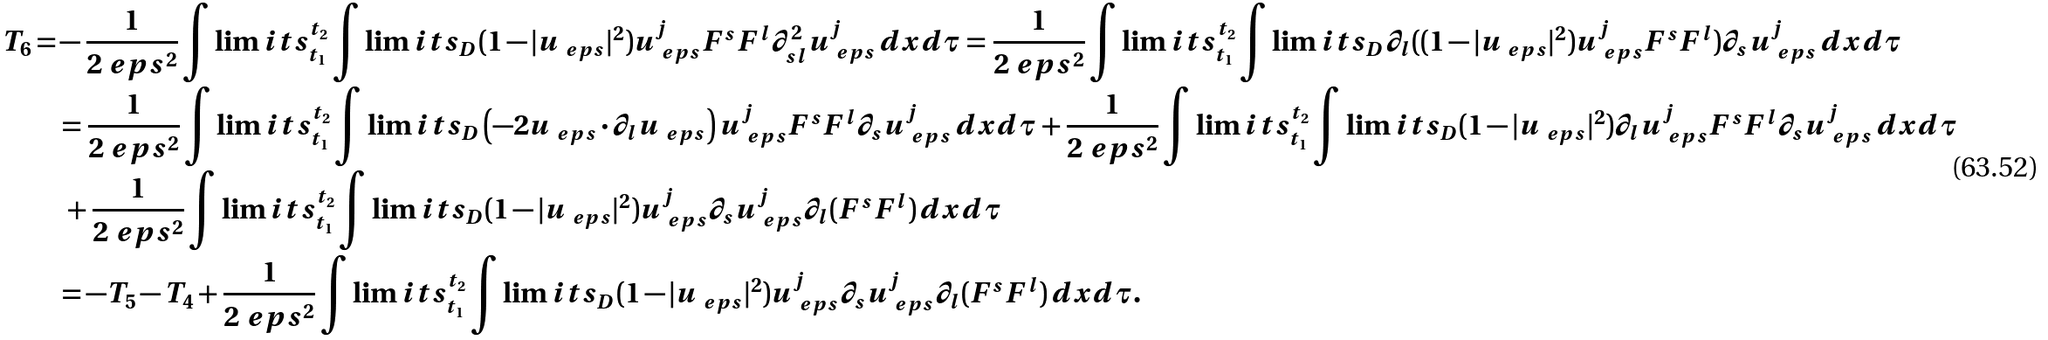<formula> <loc_0><loc_0><loc_500><loc_500>T _ { 6 } = & - \frac { 1 } { 2 \ e p s ^ { 2 } } \int \lim i t s _ { t _ { 1 } } ^ { t _ { 2 } } \int \lim i t s _ { D } ( 1 - | u _ { \ e p s } | ^ { 2 } ) u _ { \ e p s } ^ { j } F ^ { s } F ^ { l } \partial ^ { 2 } _ { s l } u _ { \ e p s } ^ { j } \, d x d \tau = \frac { 1 } { 2 \ e p s ^ { 2 } } \int \lim i t s _ { t _ { 1 } } ^ { t _ { 2 } } \int \lim i t s _ { D } \partial _ { l } ( ( 1 - | u _ { \ e p s } | ^ { 2 } ) u _ { \ e p s } ^ { j } F ^ { s } F ^ { l } ) \partial _ { s } u _ { \ e p s } ^ { j } \, d x d \tau \\ & = \frac { 1 } { 2 \ e p s ^ { 2 } } \int \lim i t s _ { t _ { 1 } } ^ { t _ { 2 } } \int \lim i t s _ { D } \left ( - 2 u _ { \ e p s } \cdot \partial _ { l } u _ { \ e p s } \right ) u _ { \ e p s } ^ { j } F ^ { s } F ^ { l } \partial _ { s } u _ { \ e p s } ^ { j } \, d x d \tau + \frac { 1 } { 2 \ e p s ^ { 2 } } \int \lim i t s _ { t _ { 1 } } ^ { t _ { 2 } } \int \lim i t s _ { D } ( 1 - | u _ { \ e p s } | ^ { 2 } ) \partial _ { l } u _ { \ e p s } ^ { j } F ^ { s } F ^ { l } \partial _ { s } u _ { \ e p s } ^ { j } \, d x d \tau \\ & \ + \frac { 1 } { 2 \ e p s ^ { 2 } } \int \lim i t s _ { t _ { 1 } } ^ { t _ { 2 } } \int \lim i t s _ { D } ( 1 - | u _ { \ e p s } | ^ { 2 } ) u _ { \ e p s } ^ { j } \partial _ { s } u _ { \ e p s } ^ { j } \partial _ { l } ( F ^ { s } F ^ { l } ) \, d x d \tau \\ & = - T _ { 5 } - T _ { 4 } + \frac { 1 } { 2 \ e p s ^ { 2 } } \int \lim i t s _ { t _ { 1 } } ^ { t _ { 2 } } \int \lim i t s _ { D } ( 1 - | u _ { \ e p s } | ^ { 2 } ) u _ { \ e p s } ^ { j } \partial _ { s } u _ { \ e p s } ^ { j } \partial _ { l } ( F ^ { s } F ^ { l } ) \, d x d \tau .</formula> 